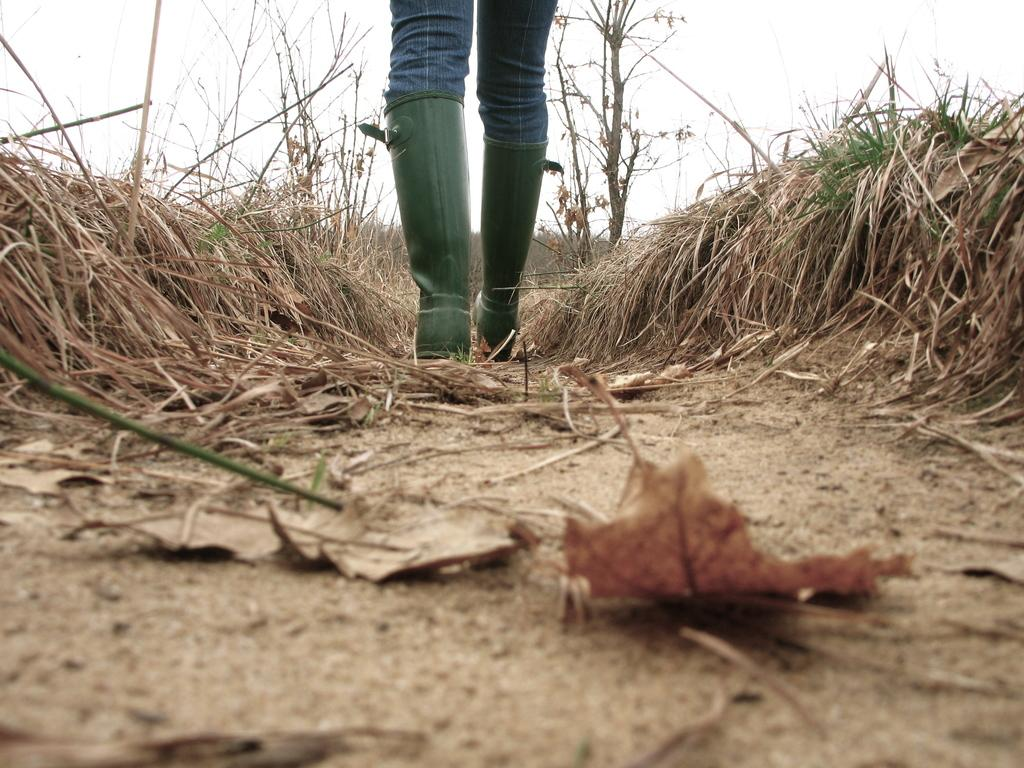What is the main subject of the image? There is a person standing in the image. What is the person standing on? The person is standing on the ground. What can be seen in the background of the image? The sky is visible in the background of the image. What type of underwear is the person wearing in the image? There is no information about the person's underwear in the image, so it cannot be determined. 